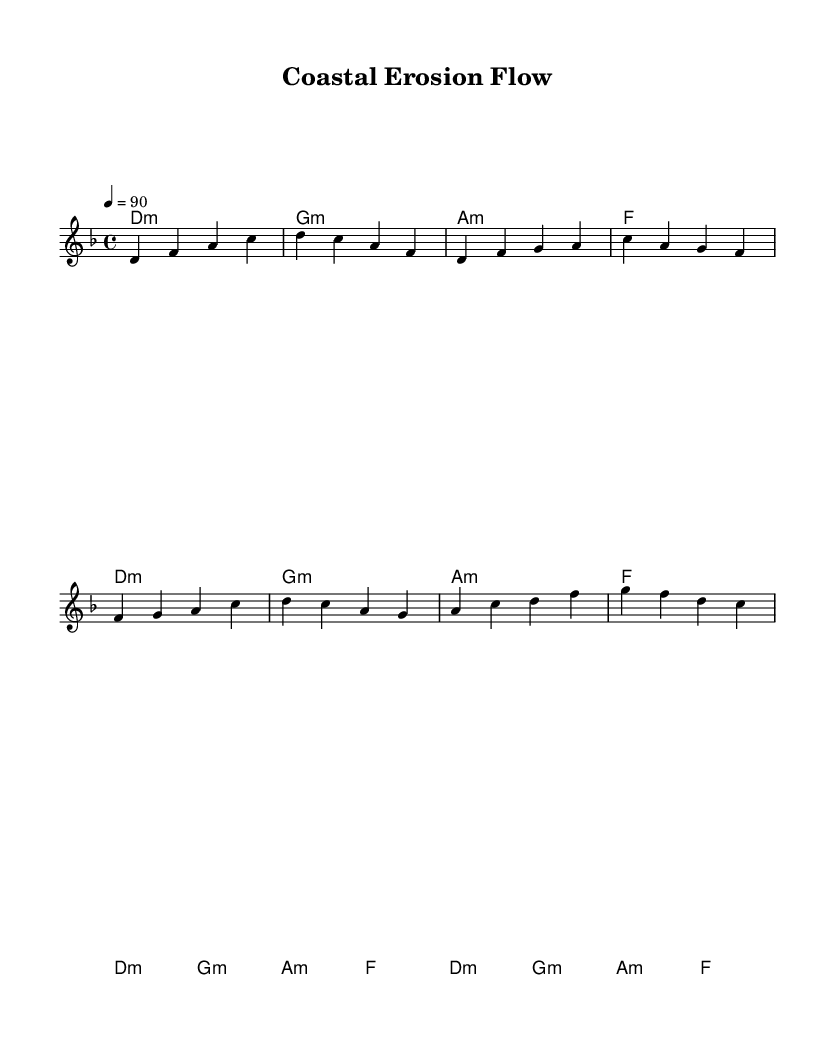What is the key signature of this music? The key signature is indicated by the absence of sharps or flats in the staff's key signature section. Since this music is set in D minor, it has one flat.
Answer: D minor What is the time signature of this music? The time signature is displayed at the beginning of the staff with two numbers, where the top number indicates beats per measure and the bottom indicates the note value that gets one beat. This music has a time signature of 4/4, often referred to as "common time."
Answer: 4/4 What is the tempo marking in this music? The tempo marking is found above the music staff indicating the speed of the piece, which is usually in beats per minute. In this case, the tempo is set to 90 beats per minute.
Answer: 90 How many measures are in the verse section of the music? To count the measures of the verse section, we observe the melody and count how many sets of 4 beats (quarter notes) are present. The verse consists of eight quarter notes, which is two measures in 4/4 time.
Answer: 2 What type of chord progression is used in the harmonies? The harmonies use a specific pattern indicated in the chord mode section of the sheet music. The chords are primarily in a minor key and follow a progression typical in various musical styles, common in Rap, which creates a moody backdrop.
Answer: Minor Which section of the music contains the bridge? The bridge section is typically a contrasting passage that can lead back to the verse or chorus, and it is indicated in the sheet music as a new melodic line. Here, it starts with the note A and includes different melody notes compared to the verse and chorus.
Answer: Bridge What is the primary theme conveyed in the lyrics of this rap? The lyrics theme can be inferred from the title "Coastal Erosion Flow," which suggests a focus on the dynamics of coastal landscapes influenced by geological processes, such as erosion and sedimentation.
Answer: Coastal erosion 